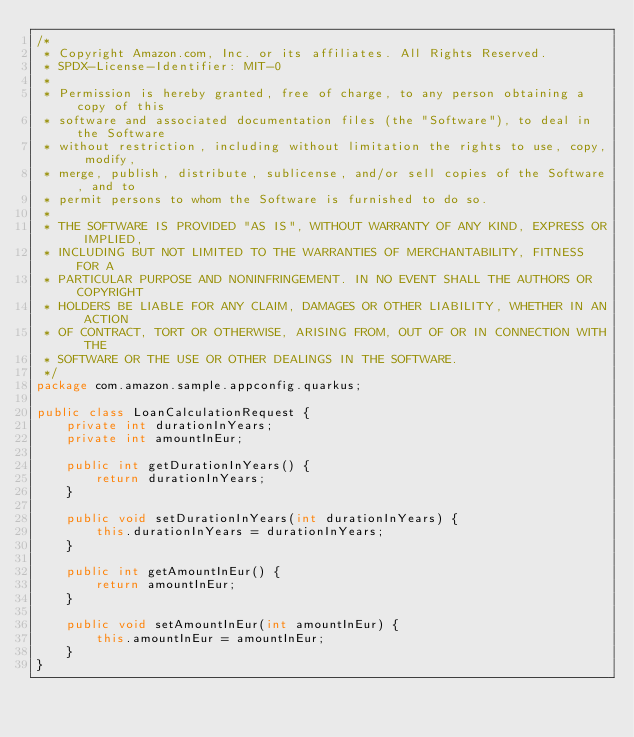Convert code to text. <code><loc_0><loc_0><loc_500><loc_500><_Java_>/*
 * Copyright Amazon.com, Inc. or its affiliates. All Rights Reserved.
 * SPDX-License-Identifier: MIT-0
 *
 * Permission is hereby granted, free of charge, to any person obtaining a copy of this
 * software and associated documentation files (the "Software"), to deal in the Software
 * without restriction, including without limitation the rights to use, copy, modify,
 * merge, publish, distribute, sublicense, and/or sell copies of the Software, and to
 * permit persons to whom the Software is furnished to do so.
 *
 * THE SOFTWARE IS PROVIDED "AS IS", WITHOUT WARRANTY OF ANY KIND, EXPRESS OR IMPLIED,
 * INCLUDING BUT NOT LIMITED TO THE WARRANTIES OF MERCHANTABILITY, FITNESS FOR A
 * PARTICULAR PURPOSE AND NONINFRINGEMENT. IN NO EVENT SHALL THE AUTHORS OR COPYRIGHT
 * HOLDERS BE LIABLE FOR ANY CLAIM, DAMAGES OR OTHER LIABILITY, WHETHER IN AN ACTION
 * OF CONTRACT, TORT OR OTHERWISE, ARISING FROM, OUT OF OR IN CONNECTION WITH THE
 * SOFTWARE OR THE USE OR OTHER DEALINGS IN THE SOFTWARE.
 */
package com.amazon.sample.appconfig.quarkus;

public class LoanCalculationRequest {
    private int durationInYears;
    private int amountInEur;

    public int getDurationInYears() {
        return durationInYears;
    }

    public void setDurationInYears(int durationInYears) {
        this.durationInYears = durationInYears;
    }

    public int getAmountInEur() {
        return amountInEur;
    }

    public void setAmountInEur(int amountInEur) {
        this.amountInEur = amountInEur;
    }
}
</code> 